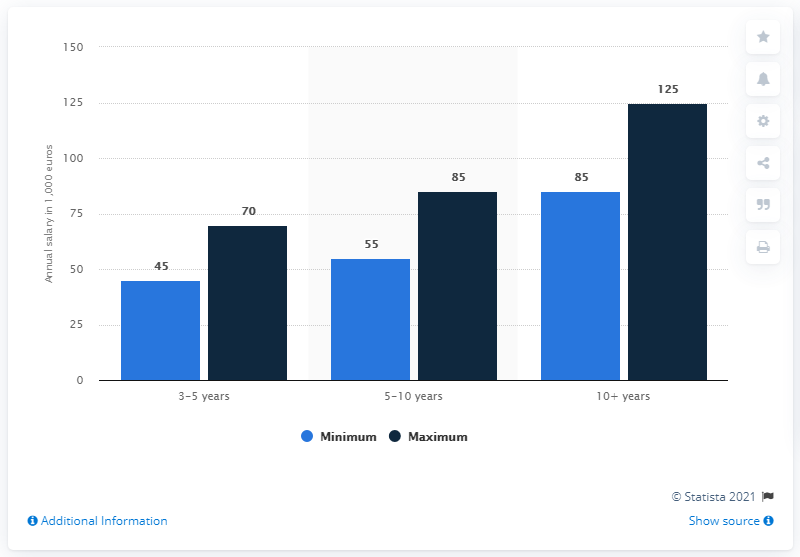Draw attention to some important aspects in this diagram. The difference between the maximum and minimum annual salary was smallest among those with 3-5 years of experience. 